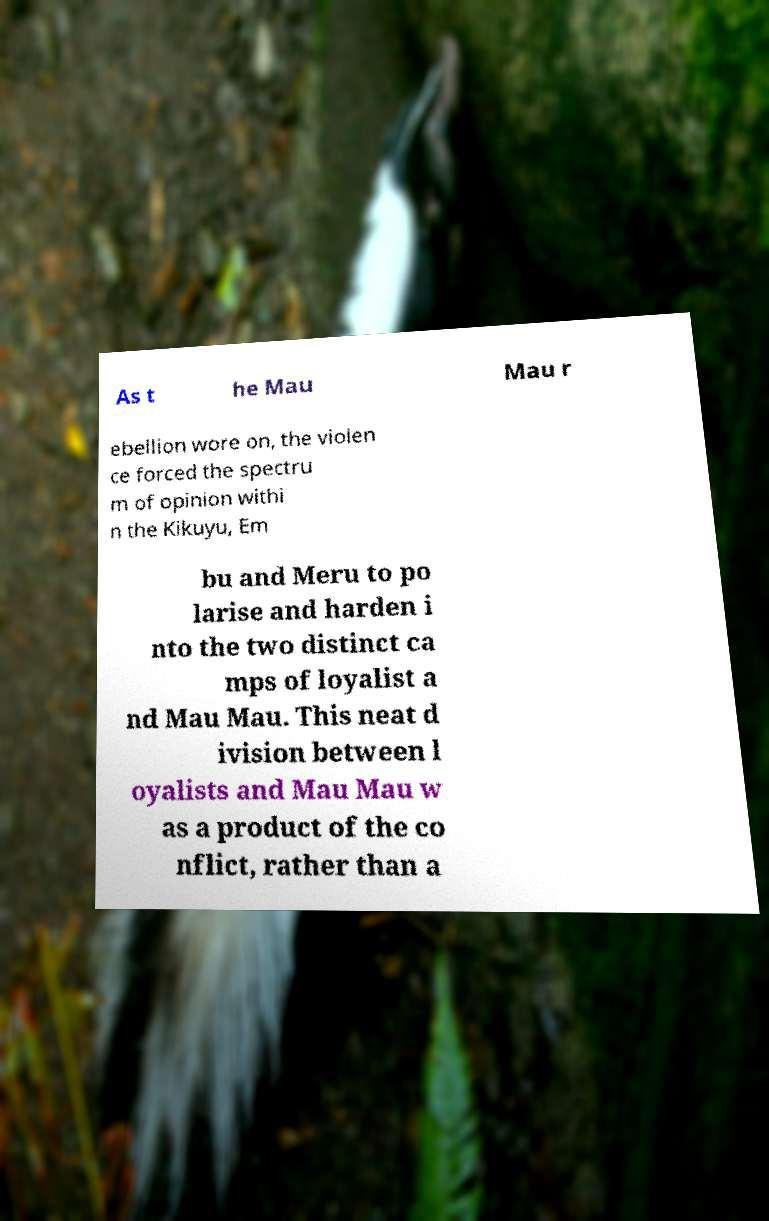Could you assist in decoding the text presented in this image and type it out clearly? As t he Mau Mau r ebellion wore on, the violen ce forced the spectru m of opinion withi n the Kikuyu, Em bu and Meru to po larise and harden i nto the two distinct ca mps of loyalist a nd Mau Mau. This neat d ivision between l oyalists and Mau Mau w as a product of the co nflict, rather than a 